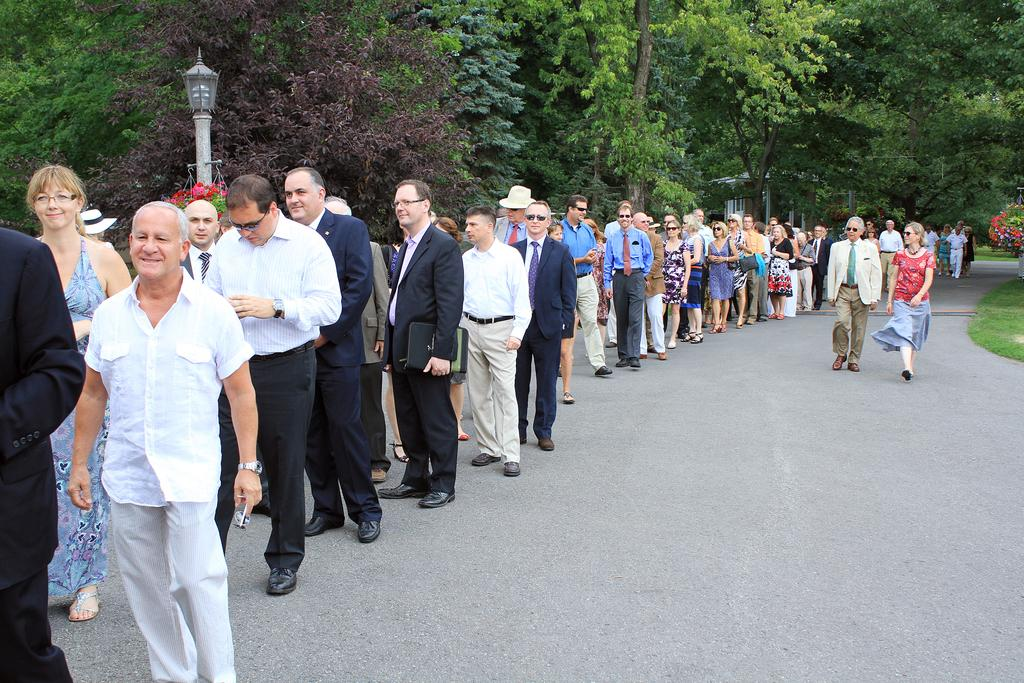What are the people in the image doing? The people in the image are standing on the road. What can be seen in the background of the image? There are trees and light poles in the background of the image. Is the queen standing on the road in the image? There is no queen present in the image; it only shows people standing on the road. 